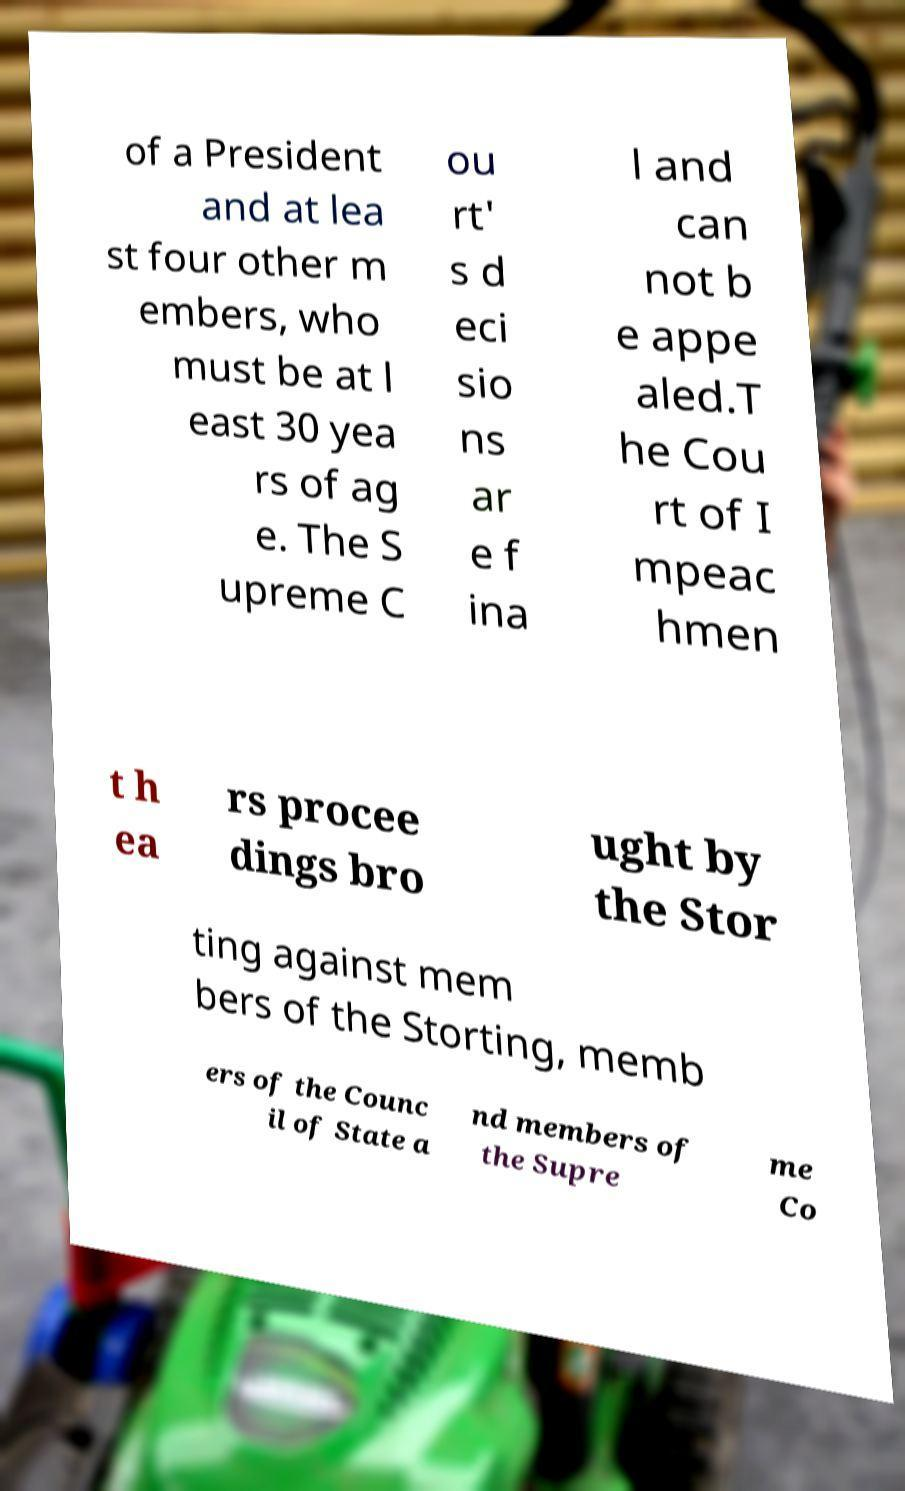Please read and relay the text visible in this image. What does it say? of a President and at lea st four other m embers, who must be at l east 30 yea rs of ag e. The S upreme C ou rt' s d eci sio ns ar e f ina l and can not b e appe aled.T he Cou rt of I mpeac hmen t h ea rs procee dings bro ught by the Stor ting against mem bers of the Storting, memb ers of the Counc il of State a nd members of the Supre me Co 